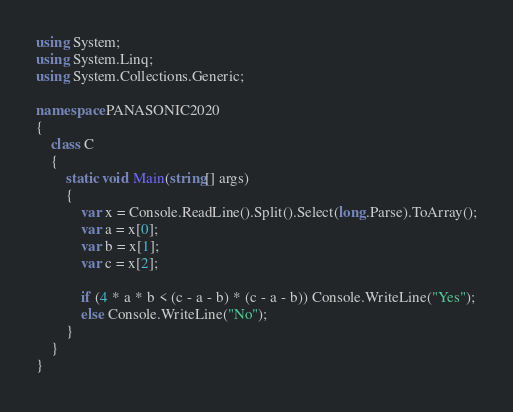<code> <loc_0><loc_0><loc_500><loc_500><_C#_>using System;
using System.Linq;
using System.Collections.Generic;

namespace PANASONIC2020
{
    class C
    {
        static void Main(string[] args)
        {
            var x = Console.ReadLine().Split().Select(long.Parse).ToArray();
            var a = x[0];
            var b = x[1];
            var c = x[2];

            if (4 * a * b < (c - a - b) * (c - a - b)) Console.WriteLine("Yes");
            else Console.WriteLine("No");
        }
    }
}
</code> 